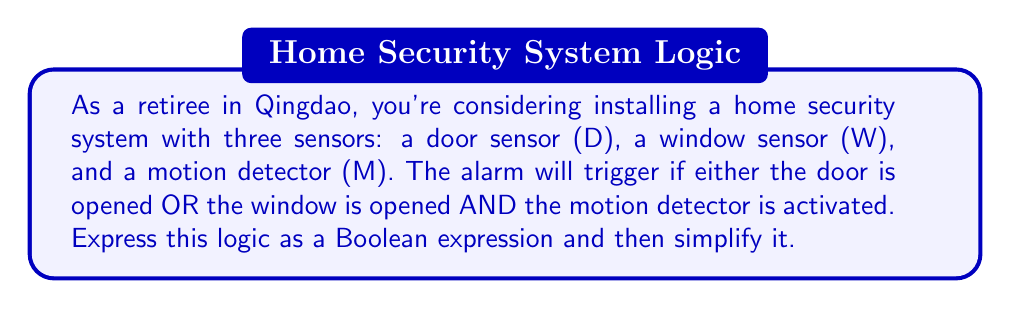Solve this math problem. Let's approach this step-by-step:

1) First, we need to express the given logic as a Boolean expression:
   $$ D + (W \cdot M) $$
   Where '+' represents OR, and '·' represents AND.

2) This expression is already quite simple, but we can verify if it can be simplified further using Boolean algebra laws.

3) We can apply the distributive law to see if it yields a simpler form:
   $$ D + (W \cdot M) = (D + W) \cdot (D + M) $$

4) However, this expanded form is actually more complex than our original expression.

5) We can also check if any of the following laws apply:
   - Idempotent law: $A + A = A$ or $A \cdot A = A$
   - Identity law: $A + 0 = A$ or $A \cdot 1 = A$
   - Null law: $A + 1 = 1$ or $A \cdot 0 = 0$
   - Absorption law: $A + (A \cdot B) = A$ or $A \cdot (A + B) = A$

6) None of these laws can be applied to further simplify our expression.

Therefore, the original expression $D + (W \cdot M)$ is already in its simplest form.
Answer: $$ D + (W \cdot M) $$ 